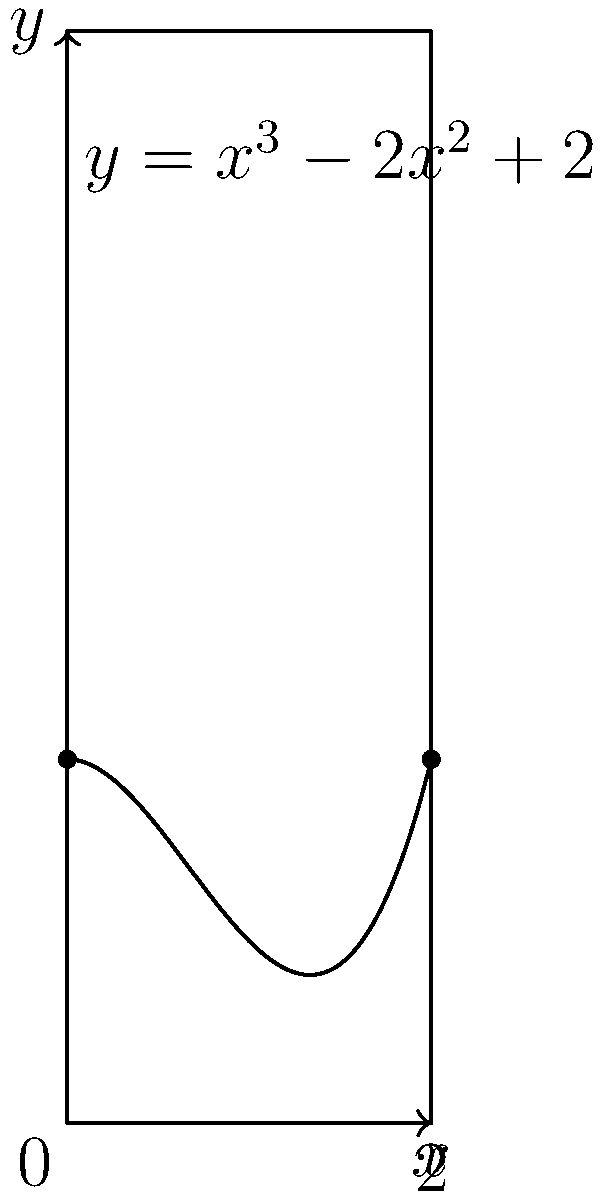Find the area bounded by the curve $y = x^3 - 2x^2 + 2$, the x-axis, and the lines $x = 0$ and $x = 2$, as shown in the figure. Use integration to calculate the area precisely. To find the area under the curve, we need to integrate the function from 0 to 2. Here's the step-by-step process:

1) The area is given by the definite integral:
   $$A = \int_0^2 (x^3 - 2x^2 + 2) dx$$

2) Integrate each term:
   $$A = \left[\frac{x^4}{4} - \frac{2x^3}{3} + 2x\right]_0^2$$

3) Evaluate the integral at the upper and lower bounds:
   $$A = \left(\frac{2^4}{4} - \frac{2(2^3)}{3} + 2(2)\right) - \left(\frac{0^4}{4} - \frac{2(0^3)}{3} + 2(0)\right)$$

4) Simplify:
   $$A = \left(4 - \frac{16}{3} + 4\right) - (0)$$
   $$A = 8 - \frac{16}{3}$$

5) Find a common denominator:
   $$A = \frac{24}{3} - \frac{16}{3} = \frac{8}{3}$$

Therefore, the area under the curve is $\frac{8}{3}$ square units.
Answer: $\frac{8}{3}$ square units 